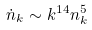<formula> <loc_0><loc_0><loc_500><loc_500>\dot { n } _ { k } \sim k ^ { 1 4 } n _ { k } ^ { 5 }</formula> 